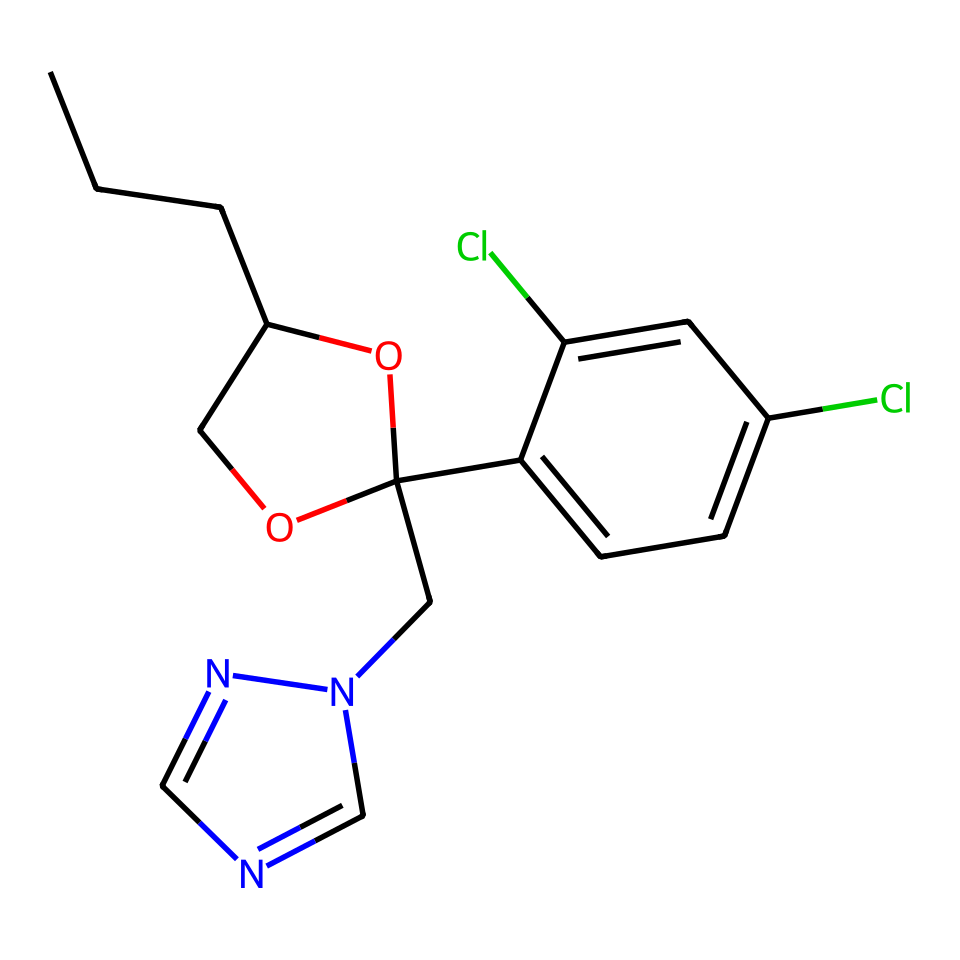What is the molecular formula of this compound? To determine the molecular formula from the SMILES representation, we must count the number of each type of atom present in the structure. The provided SMILES indicates carbon (C), hydrogen (H), nitrogen (N), and chlorine (Cl) atoms. Upon analysis, there are 18 carbons, 22 hydrogens, 4 nitrogens, and 2 chlorines. Therefore, the molecular formula is C18H22Cl2N4O.
Answer: C18H22Cl2N4O How many rings are present in the molecular structure? The structural information in the SMILES can be interpreted to identify ring systems. Observing the part 'C1...O1' indicates a ring formed with the oxygen atom and the adjacent carbon atoms. Additionally, there is another ring connected to the nitrogen 'n2cncn2'. In total, there are two distinct ring structures.
Answer: 2 What functional groups are present in this compound? A careful examination of the SMILES reveals several functional groups: an ether group (C-O connected), hydroxyl group (–OH), and a chloro group (–Cl). Each functional group contributes to the compound's behavior as a systemic fungicide.
Answer: ether, hydroxyl, chloro What are the total number of nitrogen atoms in this compound? By analyzing the SMILES representation for nitrogen atoms, we can see 'n' appears twice and the 'Cn' shows one more nitrogen. This gives us a total of 4 nitrogen atoms.
Answer: 4 Is this compound polar or nonpolar? To assess polarity, we examine the presence of polar functional groups—specifically the hydroxyl (–OH) and ether groups—which typically lead to polarity. While the structure does contain nonpolar hydrocarbon sections, the overall arrangement and functional groups lend the molecule a degree of polar character. Hence, it should be classified as polar.
Answer: polar 